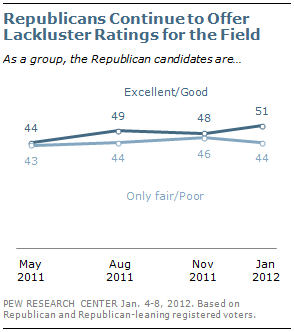Give some essential details in this illustration. The dark blue/navy blue line indicates a rating of excellent/good. The minimum gap between two lines is 1 unit. 